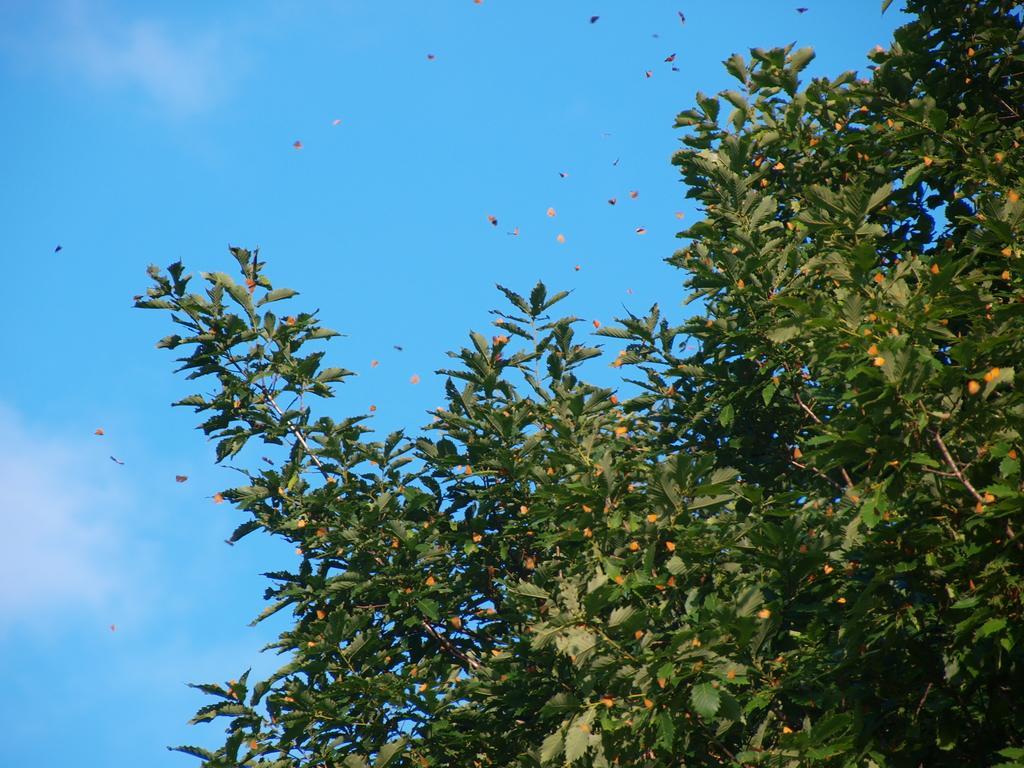Can you describe this image briefly? In this image there is a tree and butterflies and a sky. 